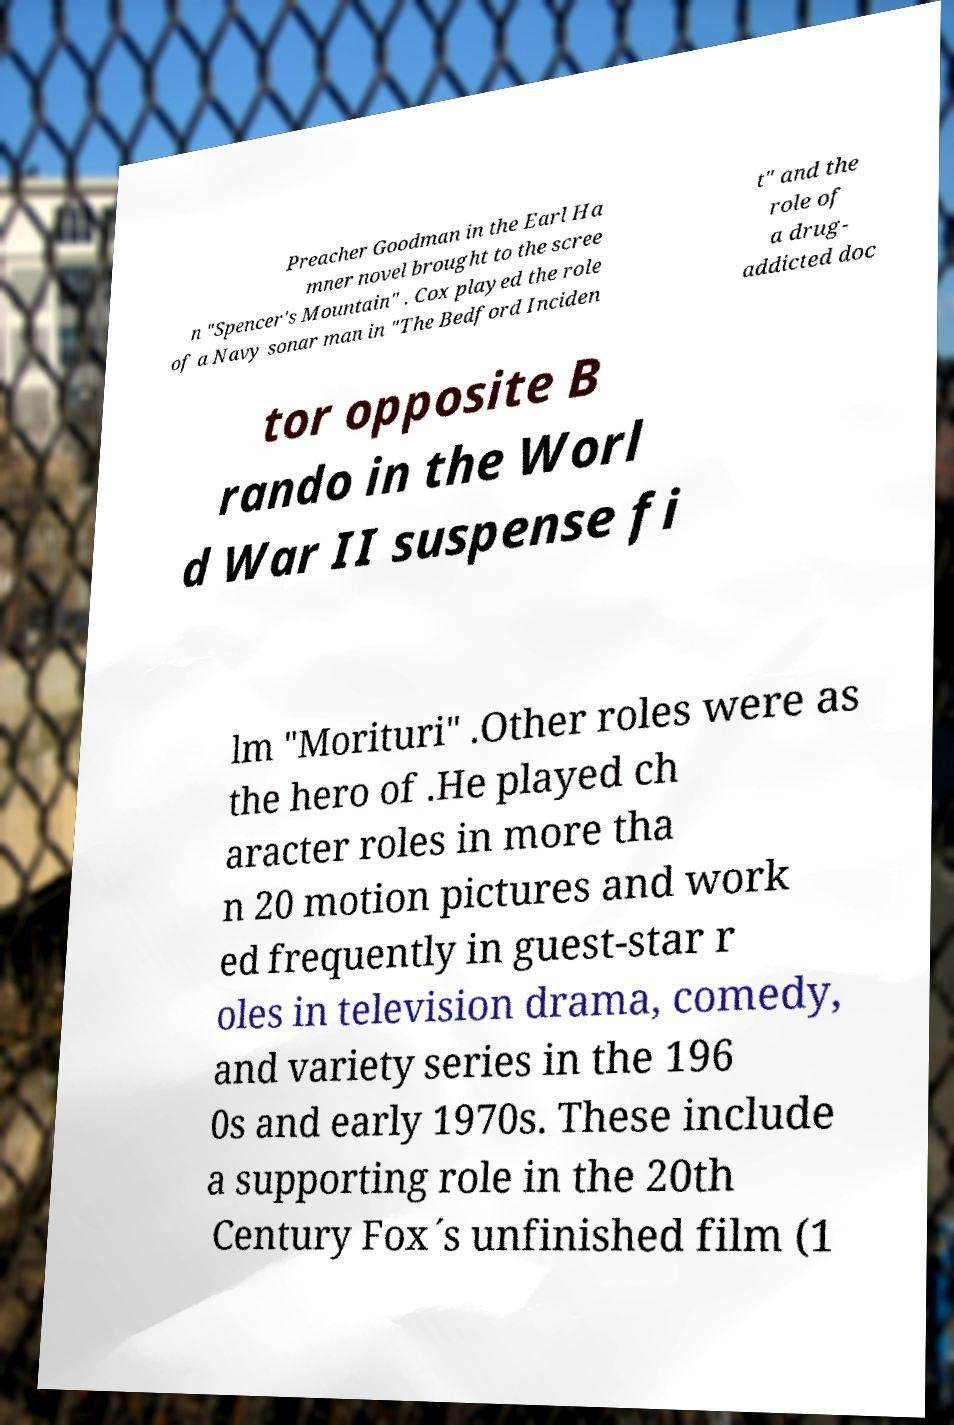For documentation purposes, I need the text within this image transcribed. Could you provide that? Preacher Goodman in the Earl Ha mner novel brought to the scree n "Spencer's Mountain" . Cox played the role of a Navy sonar man in "The Bedford Inciden t" and the role of a drug- addicted doc tor opposite B rando in the Worl d War II suspense fi lm "Morituri" .Other roles were as the hero of .He played ch aracter roles in more tha n 20 motion pictures and work ed frequently in guest-star r oles in television drama, comedy, and variety series in the 196 0s and early 1970s. These include a supporting role in the 20th Century Fox´s unfinished film (1 